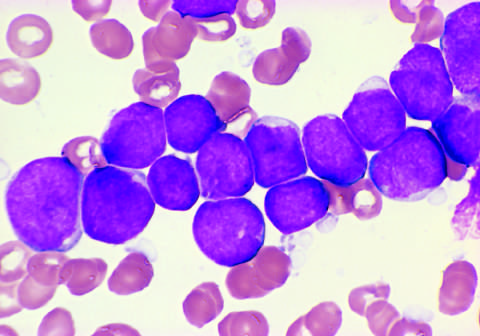s cd10 a marker expressed on a subset of alls, and tdt a specialized dna polymerase that is expressed in pre-b and pre-t cells?
Answer the question using a single word or phrase. Yes 